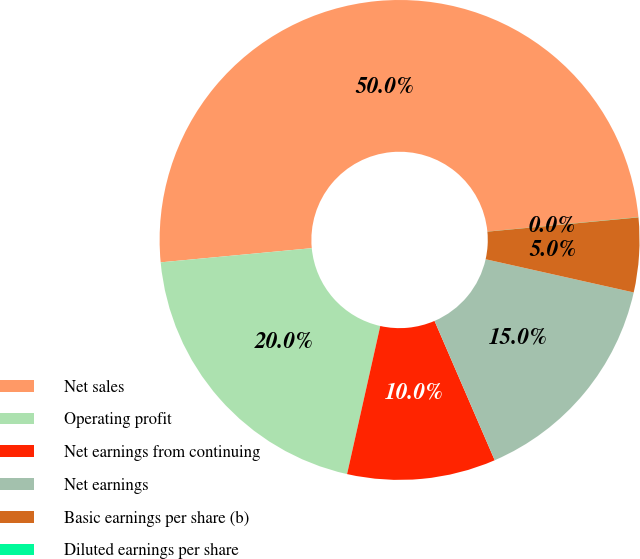<chart> <loc_0><loc_0><loc_500><loc_500><pie_chart><fcel>Net sales<fcel>Operating profit<fcel>Net earnings from continuing<fcel>Net earnings<fcel>Basic earnings per share (b)<fcel>Diluted earnings per share<nl><fcel>49.98%<fcel>20.0%<fcel>10.0%<fcel>15.0%<fcel>5.01%<fcel>0.01%<nl></chart> 